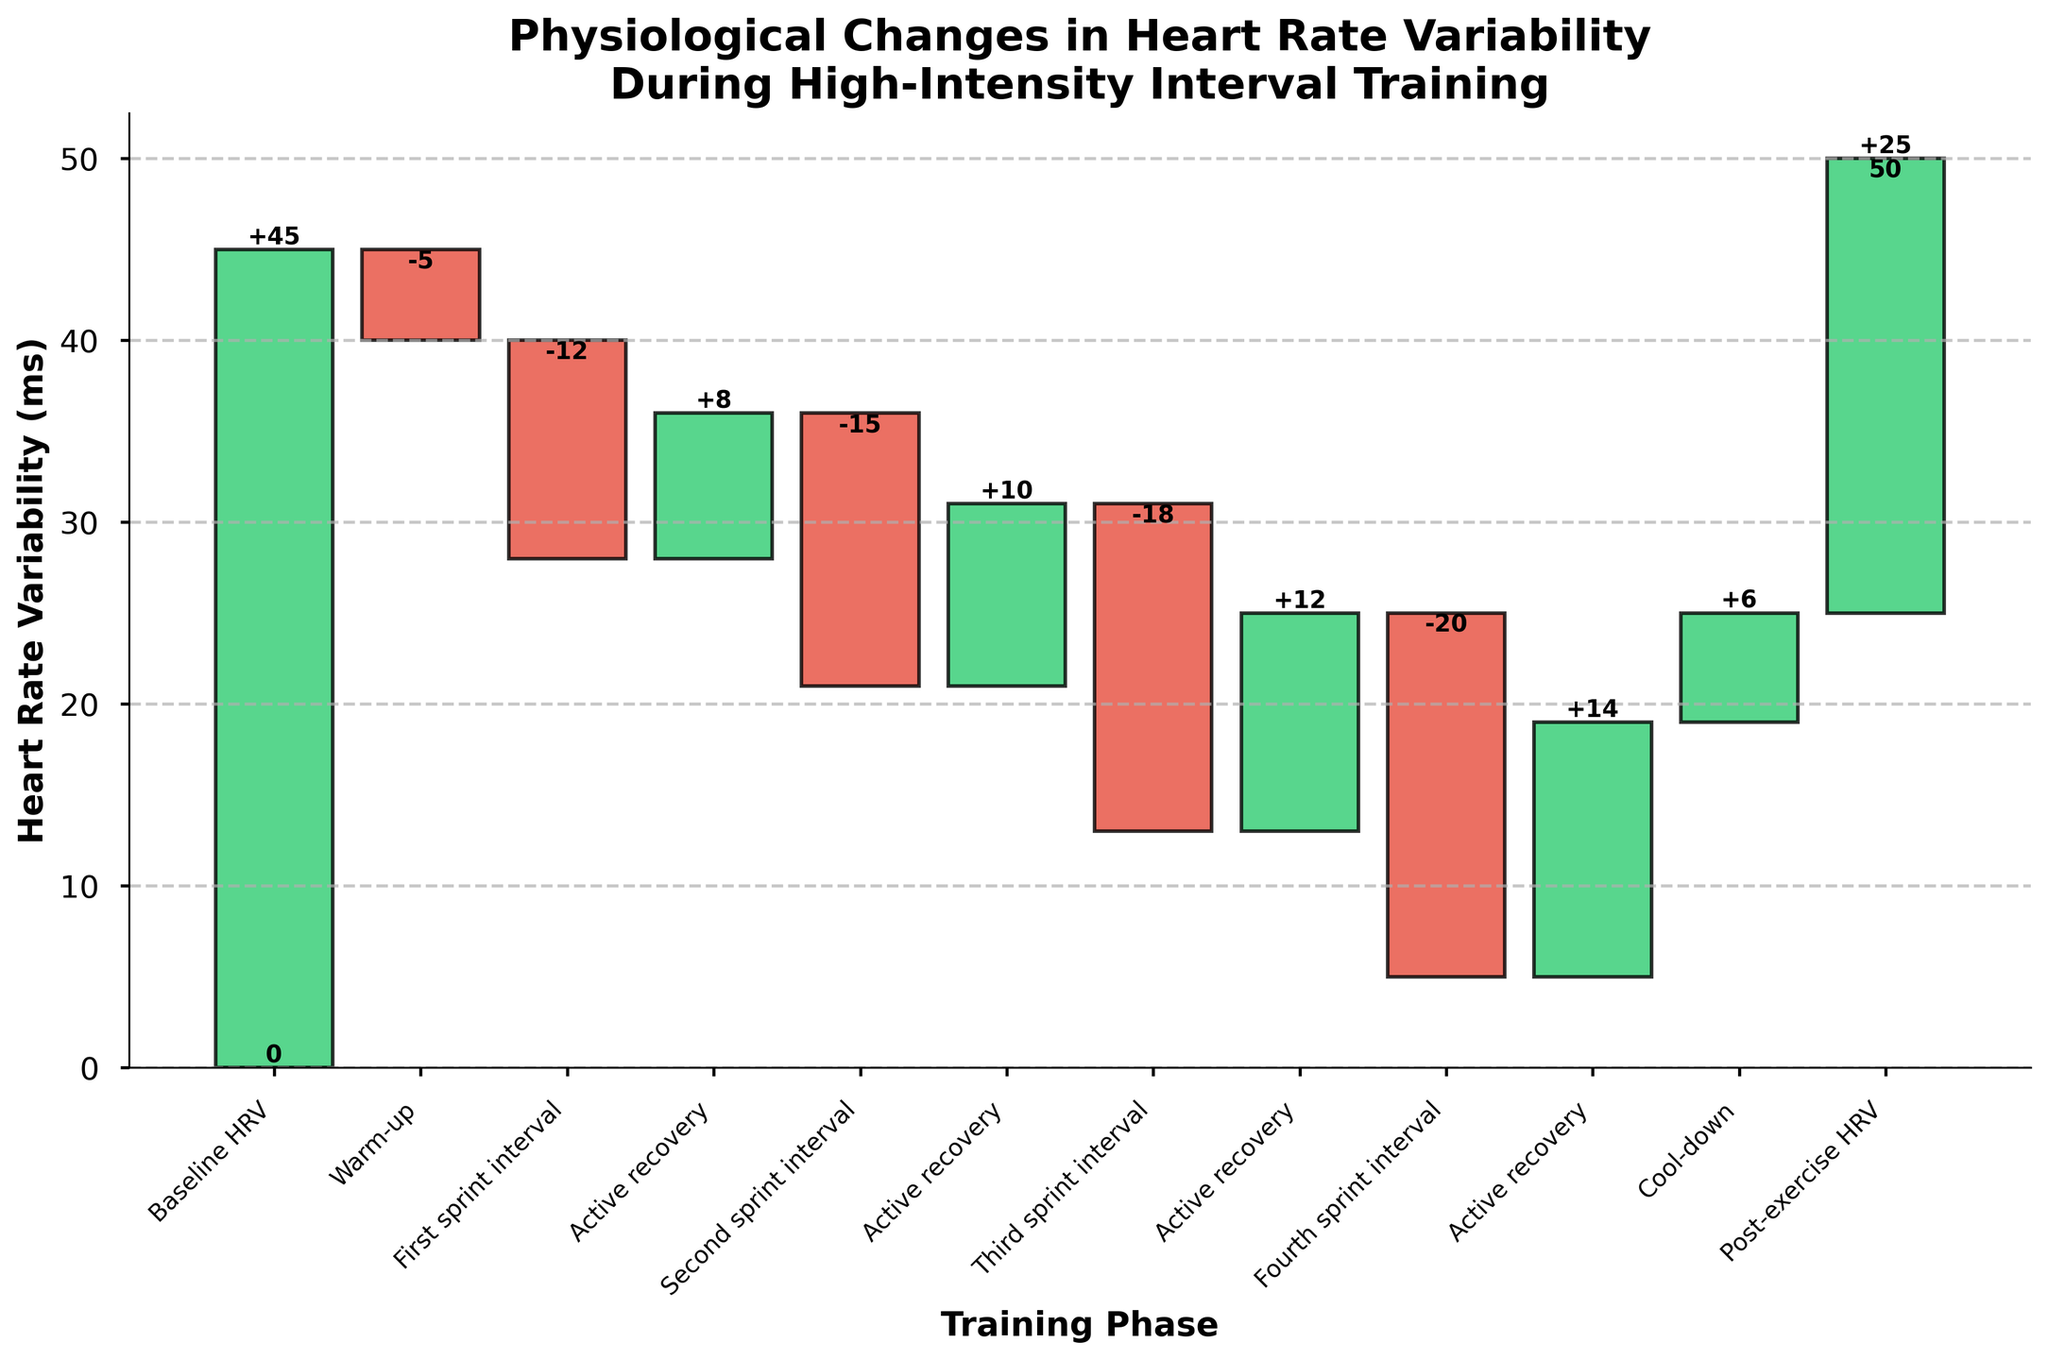What is the title of the chart? The title is displayed at the top of the chart and reads "Physiological Changes in Heart Rate Variability During High-Intensity Interval Training".
Answer: Physiological Changes in Heart Rate Variability During High-Intensity Interval Training How many phases are there in the high-intensity interval training session shown in the chart? Count the number of categories along the x-axis. Each category represents a phase.
Answer: 12 What is the heart rate variability (HRV) value after the third sprint interval? Look at the bar that corresponds to the "Third sprint interval". The cumulative HRV value after it is shown next to the bar.
Answer: 0 Which phase shows the greatest increase in HRV? Identify the bar with the largest positive value. This phase is "Active recovery" after the "Third sprint interval".
Answer: Active recovery after Third sprint interval What is the overall change in HRV from Baseline HRV to Post-exercise HRV? Calculate the difference between the initial HRV value (Baseline HRV) and the final HRV value (Post-exercise HRV). The cumulative change starts at 45 and ends at 25, so the difference is 25 - 45.
Answer: -20 How many intervals of active recovery are shown in the training session? Count the number of occurrences of the "Active recovery" category along the x-axis.
Answer: 4 What was the cumulative HRV value after the Second sprint interval? To find the cumulative value, add the initial baseline HRV (45) and the values for each category up to and including the "Second sprint interval". The sequence is: 45 (baseline) - 5 (warm-up) - 12 (first sprint interval) + 8 (active recovery) - 15 (second sprint interval).
Answer: 21 By how much did the HRV change during the warm-up phase? Read the value for the "Warm-up" phase directly from the chart. It indicates a decrease of 5.
Answer: -5 Which category has the most significant negative impact on HRV? Identify the bar with the largest negative value. The "Fourth sprint interval" has the largest negative impact with a value of -20.
Answer: Fourth sprint interval How does the HRV change from the Baseline HRV to the Warm-up phase? Look at the initial HRV value (45) and the HRV value after the warm-up (-5). The change is from 45 to 40 (45 + (-5)).
Answer: 40 